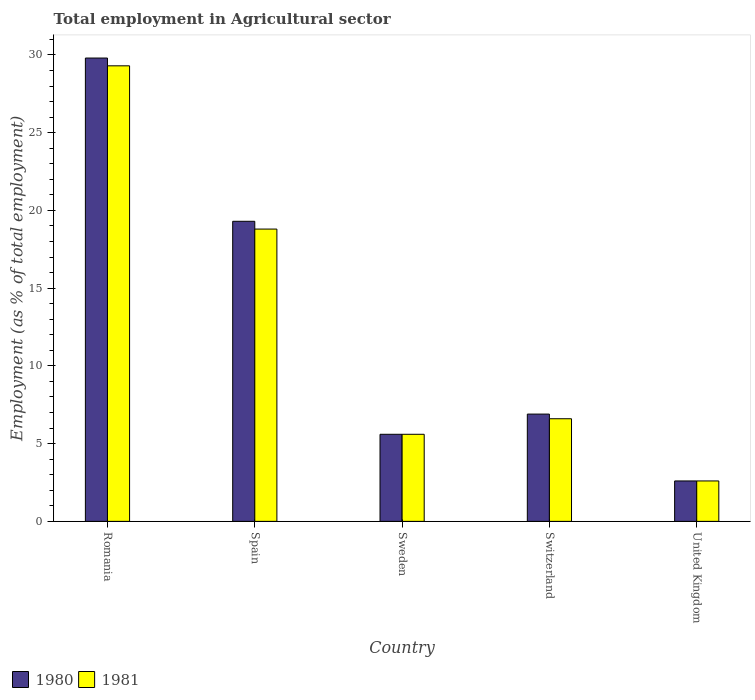How many different coloured bars are there?
Provide a short and direct response. 2. How many groups of bars are there?
Keep it short and to the point. 5. Are the number of bars on each tick of the X-axis equal?
Ensure brevity in your answer.  Yes. How many bars are there on the 3rd tick from the left?
Offer a terse response. 2. How many bars are there on the 1st tick from the right?
Provide a succinct answer. 2. What is the label of the 1st group of bars from the left?
Give a very brief answer. Romania. In how many cases, is the number of bars for a given country not equal to the number of legend labels?
Provide a short and direct response. 0. What is the employment in agricultural sector in 1981 in United Kingdom?
Offer a terse response. 2.6. Across all countries, what is the maximum employment in agricultural sector in 1980?
Give a very brief answer. 29.8. Across all countries, what is the minimum employment in agricultural sector in 1981?
Your response must be concise. 2.6. In which country was the employment in agricultural sector in 1980 maximum?
Your answer should be compact. Romania. What is the total employment in agricultural sector in 1980 in the graph?
Make the answer very short. 64.2. What is the difference between the employment in agricultural sector in 1981 in Switzerland and that in United Kingdom?
Your response must be concise. 4. What is the difference between the employment in agricultural sector in 1980 in United Kingdom and the employment in agricultural sector in 1981 in Spain?
Your answer should be compact. -16.2. What is the average employment in agricultural sector in 1980 per country?
Make the answer very short. 12.84. What is the ratio of the employment in agricultural sector in 1981 in Sweden to that in Switzerland?
Give a very brief answer. 0.85. Is the employment in agricultural sector in 1980 in Sweden less than that in United Kingdom?
Offer a very short reply. No. Is the difference between the employment in agricultural sector in 1981 in Spain and Switzerland greater than the difference between the employment in agricultural sector in 1980 in Spain and Switzerland?
Your answer should be compact. No. What is the difference between the highest and the lowest employment in agricultural sector in 1980?
Offer a terse response. 27.2. In how many countries, is the employment in agricultural sector in 1981 greater than the average employment in agricultural sector in 1981 taken over all countries?
Give a very brief answer. 2. Is the sum of the employment in agricultural sector in 1980 in Spain and United Kingdom greater than the maximum employment in agricultural sector in 1981 across all countries?
Provide a short and direct response. No. What does the 1st bar from the left in United Kingdom represents?
Make the answer very short. 1980. What does the 1st bar from the right in Spain represents?
Make the answer very short. 1981. How many bars are there?
Keep it short and to the point. 10. How many countries are there in the graph?
Make the answer very short. 5. What is the difference between two consecutive major ticks on the Y-axis?
Provide a short and direct response. 5. Are the values on the major ticks of Y-axis written in scientific E-notation?
Keep it short and to the point. No. Does the graph contain any zero values?
Keep it short and to the point. No. Does the graph contain grids?
Your answer should be compact. No. What is the title of the graph?
Give a very brief answer. Total employment in Agricultural sector. Does "1969" appear as one of the legend labels in the graph?
Keep it short and to the point. No. What is the label or title of the Y-axis?
Ensure brevity in your answer.  Employment (as % of total employment). What is the Employment (as % of total employment) of 1980 in Romania?
Keep it short and to the point. 29.8. What is the Employment (as % of total employment) in 1981 in Romania?
Your response must be concise. 29.3. What is the Employment (as % of total employment) of 1980 in Spain?
Your response must be concise. 19.3. What is the Employment (as % of total employment) in 1981 in Spain?
Offer a terse response. 18.8. What is the Employment (as % of total employment) in 1980 in Sweden?
Your response must be concise. 5.6. What is the Employment (as % of total employment) of 1981 in Sweden?
Ensure brevity in your answer.  5.6. What is the Employment (as % of total employment) of 1980 in Switzerland?
Your response must be concise. 6.9. What is the Employment (as % of total employment) of 1981 in Switzerland?
Ensure brevity in your answer.  6.6. What is the Employment (as % of total employment) in 1980 in United Kingdom?
Offer a terse response. 2.6. What is the Employment (as % of total employment) of 1981 in United Kingdom?
Your answer should be very brief. 2.6. Across all countries, what is the maximum Employment (as % of total employment) in 1980?
Provide a succinct answer. 29.8. Across all countries, what is the maximum Employment (as % of total employment) of 1981?
Offer a very short reply. 29.3. Across all countries, what is the minimum Employment (as % of total employment) in 1980?
Your answer should be compact. 2.6. Across all countries, what is the minimum Employment (as % of total employment) in 1981?
Offer a terse response. 2.6. What is the total Employment (as % of total employment) of 1980 in the graph?
Give a very brief answer. 64.2. What is the total Employment (as % of total employment) of 1981 in the graph?
Your answer should be compact. 62.9. What is the difference between the Employment (as % of total employment) of 1981 in Romania and that in Spain?
Your response must be concise. 10.5. What is the difference between the Employment (as % of total employment) of 1980 in Romania and that in Sweden?
Ensure brevity in your answer.  24.2. What is the difference between the Employment (as % of total employment) of 1981 in Romania and that in Sweden?
Provide a succinct answer. 23.7. What is the difference between the Employment (as % of total employment) in 1980 in Romania and that in Switzerland?
Your answer should be very brief. 22.9. What is the difference between the Employment (as % of total employment) in 1981 in Romania and that in Switzerland?
Give a very brief answer. 22.7. What is the difference between the Employment (as % of total employment) in 1980 in Romania and that in United Kingdom?
Ensure brevity in your answer.  27.2. What is the difference between the Employment (as % of total employment) in 1981 in Romania and that in United Kingdom?
Your response must be concise. 26.7. What is the difference between the Employment (as % of total employment) of 1980 in Spain and that in Sweden?
Offer a terse response. 13.7. What is the difference between the Employment (as % of total employment) of 1981 in Spain and that in United Kingdom?
Give a very brief answer. 16.2. What is the difference between the Employment (as % of total employment) of 1981 in Sweden and that in Switzerland?
Provide a short and direct response. -1. What is the difference between the Employment (as % of total employment) in 1981 in Sweden and that in United Kingdom?
Offer a very short reply. 3. What is the difference between the Employment (as % of total employment) of 1980 in Switzerland and that in United Kingdom?
Your answer should be compact. 4.3. What is the difference between the Employment (as % of total employment) of 1980 in Romania and the Employment (as % of total employment) of 1981 in Sweden?
Make the answer very short. 24.2. What is the difference between the Employment (as % of total employment) in 1980 in Romania and the Employment (as % of total employment) in 1981 in Switzerland?
Ensure brevity in your answer.  23.2. What is the difference between the Employment (as % of total employment) of 1980 in Romania and the Employment (as % of total employment) of 1981 in United Kingdom?
Provide a succinct answer. 27.2. What is the difference between the Employment (as % of total employment) in 1980 in Spain and the Employment (as % of total employment) in 1981 in Switzerland?
Give a very brief answer. 12.7. What is the difference between the Employment (as % of total employment) of 1980 in Spain and the Employment (as % of total employment) of 1981 in United Kingdom?
Provide a short and direct response. 16.7. What is the difference between the Employment (as % of total employment) of 1980 in Sweden and the Employment (as % of total employment) of 1981 in Switzerland?
Keep it short and to the point. -1. What is the difference between the Employment (as % of total employment) in 1980 in Sweden and the Employment (as % of total employment) in 1981 in United Kingdom?
Offer a very short reply. 3. What is the difference between the Employment (as % of total employment) in 1980 in Switzerland and the Employment (as % of total employment) in 1981 in United Kingdom?
Your answer should be very brief. 4.3. What is the average Employment (as % of total employment) in 1980 per country?
Give a very brief answer. 12.84. What is the average Employment (as % of total employment) in 1981 per country?
Ensure brevity in your answer.  12.58. What is the difference between the Employment (as % of total employment) in 1980 and Employment (as % of total employment) in 1981 in Romania?
Your answer should be very brief. 0.5. What is the difference between the Employment (as % of total employment) of 1980 and Employment (as % of total employment) of 1981 in Sweden?
Provide a succinct answer. 0. What is the ratio of the Employment (as % of total employment) in 1980 in Romania to that in Spain?
Your response must be concise. 1.54. What is the ratio of the Employment (as % of total employment) of 1981 in Romania to that in Spain?
Make the answer very short. 1.56. What is the ratio of the Employment (as % of total employment) in 1980 in Romania to that in Sweden?
Your answer should be very brief. 5.32. What is the ratio of the Employment (as % of total employment) of 1981 in Romania to that in Sweden?
Make the answer very short. 5.23. What is the ratio of the Employment (as % of total employment) in 1980 in Romania to that in Switzerland?
Offer a terse response. 4.32. What is the ratio of the Employment (as % of total employment) of 1981 in Romania to that in Switzerland?
Your answer should be compact. 4.44. What is the ratio of the Employment (as % of total employment) of 1980 in Romania to that in United Kingdom?
Give a very brief answer. 11.46. What is the ratio of the Employment (as % of total employment) in 1981 in Romania to that in United Kingdom?
Make the answer very short. 11.27. What is the ratio of the Employment (as % of total employment) of 1980 in Spain to that in Sweden?
Your answer should be very brief. 3.45. What is the ratio of the Employment (as % of total employment) in 1981 in Spain to that in Sweden?
Make the answer very short. 3.36. What is the ratio of the Employment (as % of total employment) of 1980 in Spain to that in Switzerland?
Give a very brief answer. 2.8. What is the ratio of the Employment (as % of total employment) of 1981 in Spain to that in Switzerland?
Offer a very short reply. 2.85. What is the ratio of the Employment (as % of total employment) in 1980 in Spain to that in United Kingdom?
Ensure brevity in your answer.  7.42. What is the ratio of the Employment (as % of total employment) of 1981 in Spain to that in United Kingdom?
Your answer should be compact. 7.23. What is the ratio of the Employment (as % of total employment) of 1980 in Sweden to that in Switzerland?
Give a very brief answer. 0.81. What is the ratio of the Employment (as % of total employment) in 1981 in Sweden to that in Switzerland?
Ensure brevity in your answer.  0.85. What is the ratio of the Employment (as % of total employment) in 1980 in Sweden to that in United Kingdom?
Provide a succinct answer. 2.15. What is the ratio of the Employment (as % of total employment) in 1981 in Sweden to that in United Kingdom?
Your answer should be very brief. 2.15. What is the ratio of the Employment (as % of total employment) of 1980 in Switzerland to that in United Kingdom?
Offer a terse response. 2.65. What is the ratio of the Employment (as % of total employment) in 1981 in Switzerland to that in United Kingdom?
Your answer should be very brief. 2.54. What is the difference between the highest and the lowest Employment (as % of total employment) in 1980?
Your answer should be very brief. 27.2. What is the difference between the highest and the lowest Employment (as % of total employment) of 1981?
Make the answer very short. 26.7. 